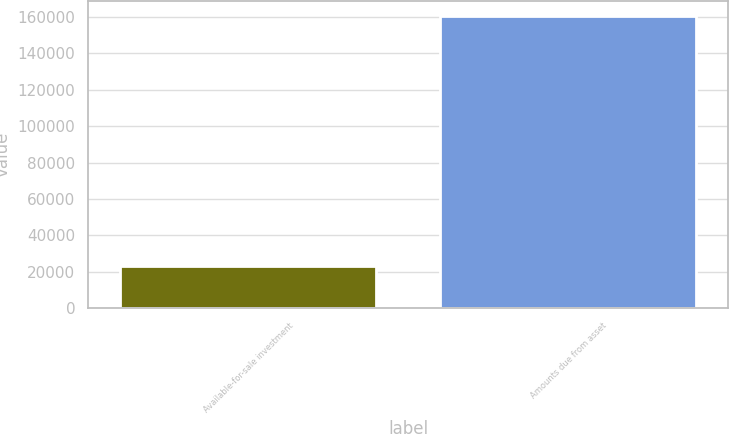Convert chart to OTSL. <chart><loc_0><loc_0><loc_500><loc_500><bar_chart><fcel>Available-for-sale investment<fcel>Amounts due from asset<nl><fcel>23339<fcel>160690<nl></chart> 